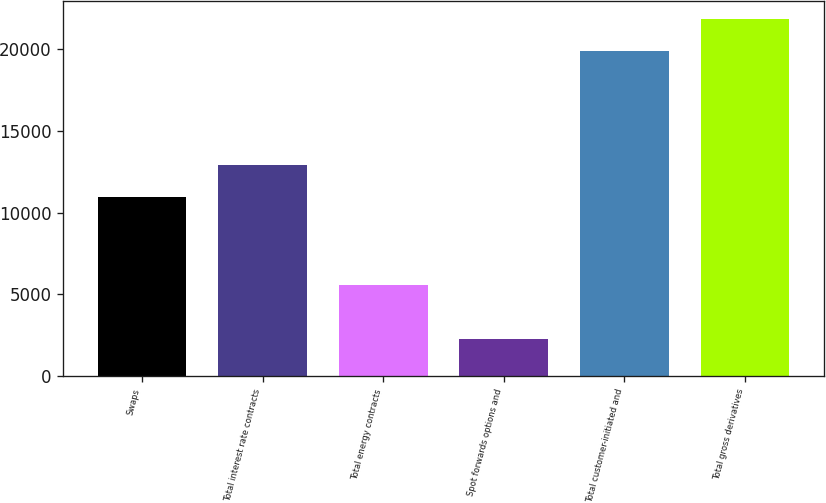Convert chart to OTSL. <chart><loc_0><loc_0><loc_500><loc_500><bar_chart><fcel>Swaps<fcel>Total interest rate contracts<fcel>Total energy contracts<fcel>Spot forwards options and<fcel>Total customer-initiated and<fcel>Total gross derivatives<nl><fcel>10952<fcel>12904.8<fcel>5561<fcel>2253<fcel>19856<fcel>21808.8<nl></chart> 